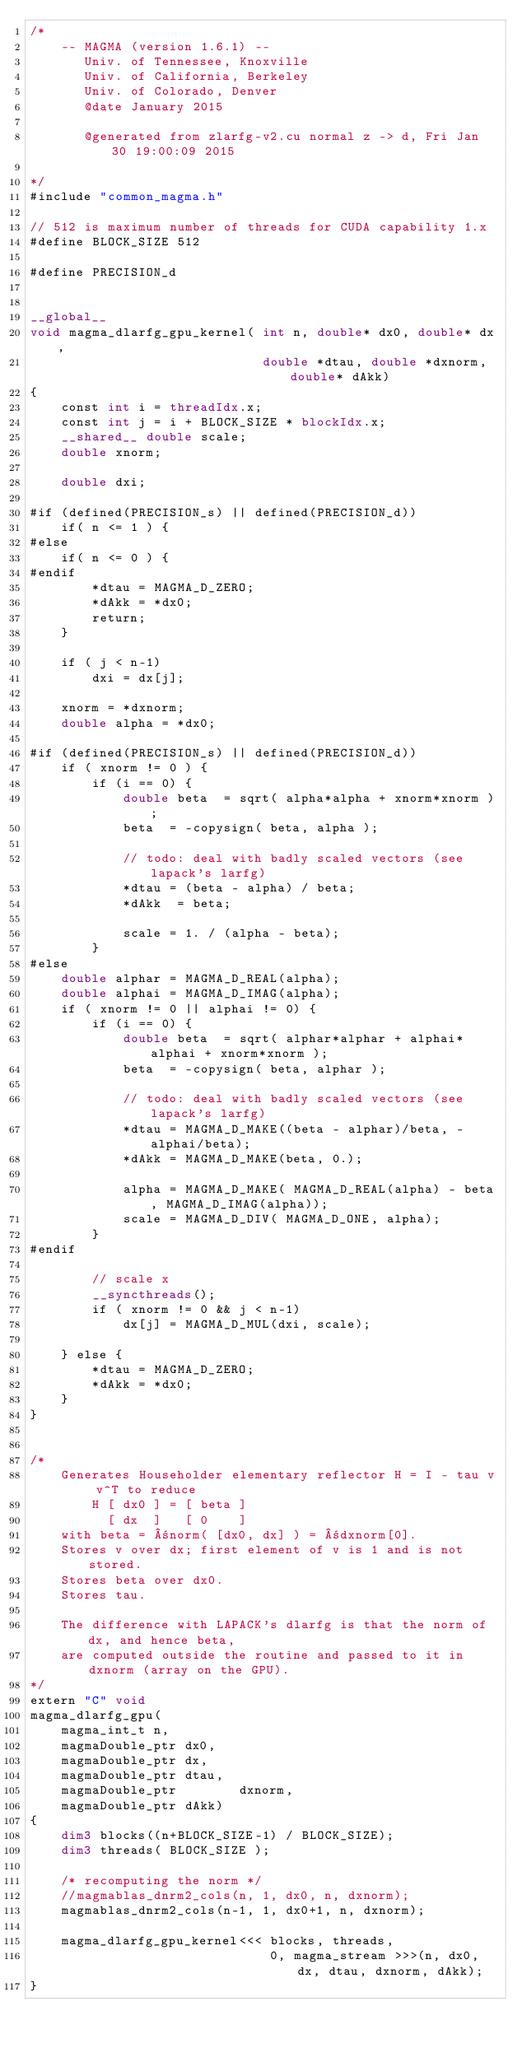<code> <loc_0><loc_0><loc_500><loc_500><_Cuda_>/*
    -- MAGMA (version 1.6.1) --
       Univ. of Tennessee, Knoxville
       Univ. of California, Berkeley
       Univ. of Colorado, Denver
       @date January 2015

       @generated from zlarfg-v2.cu normal z -> d, Fri Jan 30 19:00:09 2015

*/
#include "common_magma.h"

// 512 is maximum number of threads for CUDA capability 1.x
#define BLOCK_SIZE 512

#define PRECISION_d


__global__
void magma_dlarfg_gpu_kernel( int n, double* dx0, double* dx,
                              double *dtau, double *dxnorm, double* dAkk)
{
    const int i = threadIdx.x;
    const int j = i + BLOCK_SIZE * blockIdx.x;
    __shared__ double scale;
    double xnorm;

    double dxi;

#if (defined(PRECISION_s) || defined(PRECISION_d))
    if( n <= 1 ) {
#else
    if( n <= 0 ) {
#endif
        *dtau = MAGMA_D_ZERO;
        *dAkk = *dx0;
        return;
    }

    if ( j < n-1)
        dxi = dx[j];

    xnorm = *dxnorm;
    double alpha = *dx0;

#if (defined(PRECISION_s) || defined(PRECISION_d))
    if ( xnorm != 0 ) {
        if (i == 0) {  
            double beta  = sqrt( alpha*alpha + xnorm*xnorm );
            beta  = -copysign( beta, alpha );

            // todo: deal with badly scaled vectors (see lapack's larfg)
            *dtau = (beta - alpha) / beta;
            *dAkk  = beta;

            scale = 1. / (alpha - beta);
        }
#else
    double alphar = MAGMA_D_REAL(alpha);
    double alphai = MAGMA_D_IMAG(alpha);
    if ( xnorm != 0 || alphai != 0) {
        if (i == 0) {
            double beta  = sqrt( alphar*alphar + alphai*alphai + xnorm*xnorm );
            beta  = -copysign( beta, alphar );

            // todo: deal with badly scaled vectors (see lapack's larfg)
            *dtau = MAGMA_D_MAKE((beta - alphar)/beta, -alphai/beta);
            *dAkk = MAGMA_D_MAKE(beta, 0.);

            alpha = MAGMA_D_MAKE( MAGMA_D_REAL(alpha) - beta, MAGMA_D_IMAG(alpha));
            scale = MAGMA_D_DIV( MAGMA_D_ONE, alpha);
        }
#endif

        // scale x
        __syncthreads();
        if ( xnorm != 0 && j < n-1)
            dx[j] = MAGMA_D_MUL(dxi, scale);

    } else {
        *dtau = MAGMA_D_ZERO;
        *dAkk = *dx0; 
    }
}


/*
    Generates Householder elementary reflector H = I - tau v v^T to reduce
        H [ dx0 ] = [ beta ]
          [ dx  ]   [ 0    ]
    with beta = ±norm( [dx0, dx] ) = ±dxnorm[0].
    Stores v over dx; first element of v is 1 and is not stored.
    Stores beta over dx0.
    Stores tau.  
    
    The difference with LAPACK's dlarfg is that the norm of dx, and hence beta,
    are computed outside the routine and passed to it in dxnorm (array on the GPU).
*/
extern "C" void
magma_dlarfg_gpu(
    magma_int_t n,
    magmaDouble_ptr dx0,
    magmaDouble_ptr dx,
    magmaDouble_ptr dtau,
    magmaDouble_ptr        dxnorm,
    magmaDouble_ptr dAkk)
{
    dim3 blocks((n+BLOCK_SIZE-1) / BLOCK_SIZE);
    dim3 threads( BLOCK_SIZE );

    /* recomputing the norm */
    //magmablas_dnrm2_cols(n, 1, dx0, n, dxnorm);
    magmablas_dnrm2_cols(n-1, 1, dx0+1, n, dxnorm);

    magma_dlarfg_gpu_kernel<<< blocks, threads,
                               0, magma_stream >>>(n, dx0, dx, dtau, dxnorm, dAkk);
}
</code> 